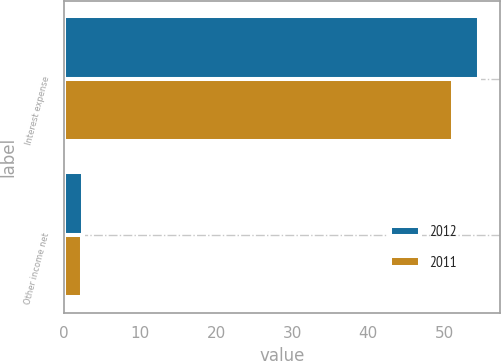<chart> <loc_0><loc_0><loc_500><loc_500><stacked_bar_chart><ecel><fcel>Interest expense<fcel>Other income net<nl><fcel>2012<fcel>54.6<fcel>2.4<nl><fcel>2011<fcel>51.2<fcel>2.3<nl></chart> 